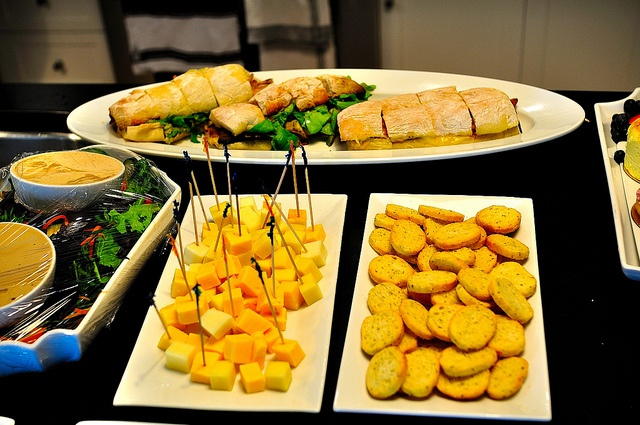Describe the objects in this image and their specific colors. I can see dining table in black, orange, khaki, and gold tones, sandwich in black, orange, and tan tones, sandwich in black, orange, olive, and gold tones, sandwich in black, orange, gold, and olive tones, and bowl in black, orange, gold, and gray tones in this image. 